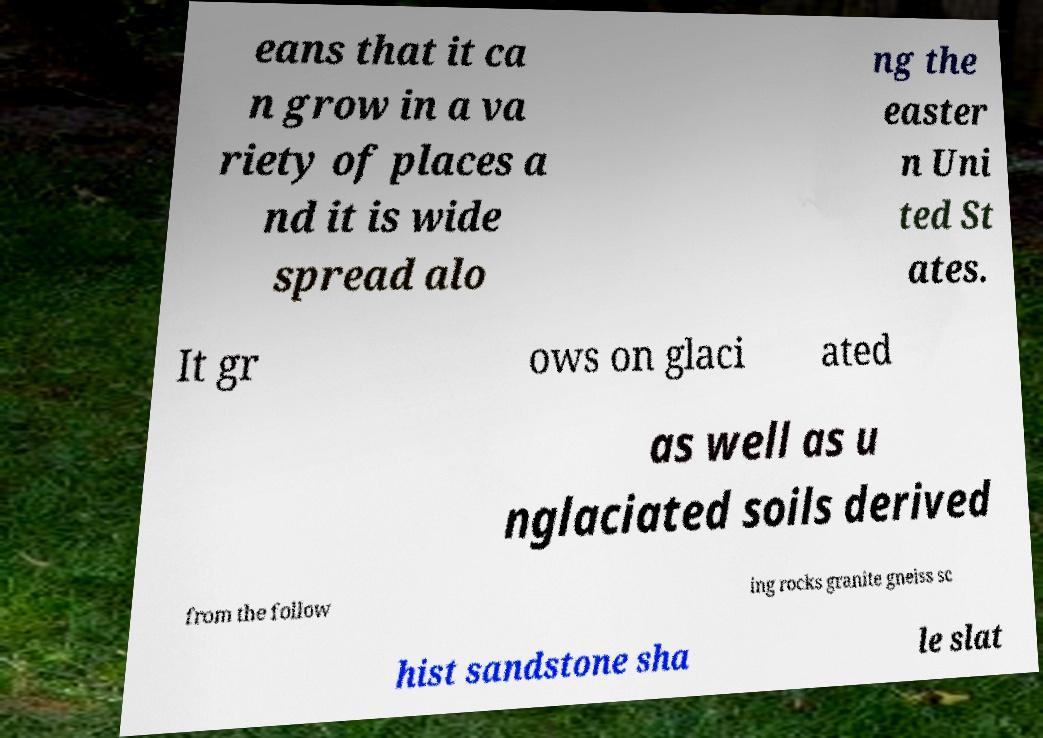For documentation purposes, I need the text within this image transcribed. Could you provide that? eans that it ca n grow in a va riety of places a nd it is wide spread alo ng the easter n Uni ted St ates. It gr ows on glaci ated as well as u nglaciated soils derived from the follow ing rocks granite gneiss sc hist sandstone sha le slat 